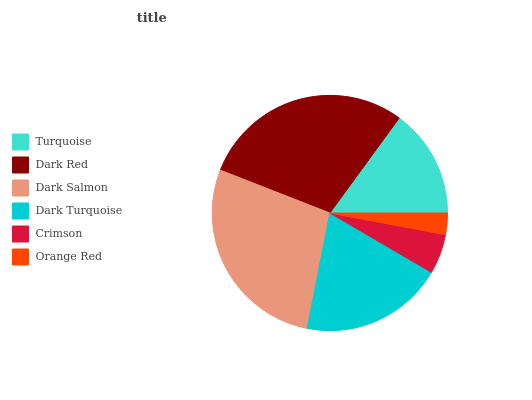Is Orange Red the minimum?
Answer yes or no. Yes. Is Dark Red the maximum?
Answer yes or no. Yes. Is Dark Salmon the minimum?
Answer yes or no. No. Is Dark Salmon the maximum?
Answer yes or no. No. Is Dark Red greater than Dark Salmon?
Answer yes or no. Yes. Is Dark Salmon less than Dark Red?
Answer yes or no. Yes. Is Dark Salmon greater than Dark Red?
Answer yes or no. No. Is Dark Red less than Dark Salmon?
Answer yes or no. No. Is Dark Turquoise the high median?
Answer yes or no. Yes. Is Turquoise the low median?
Answer yes or no. Yes. Is Crimson the high median?
Answer yes or no. No. Is Crimson the low median?
Answer yes or no. No. 